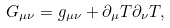Convert formula to latex. <formula><loc_0><loc_0><loc_500><loc_500>G _ { \mu \nu } = g _ { \mu \nu } + \partial _ { \mu } T \partial _ { \nu } T ,</formula> 